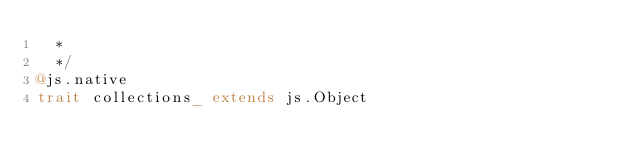<code> <loc_0><loc_0><loc_500><loc_500><_Scala_>  *
  */
@js.native
trait collections_ extends js.Object

</code> 